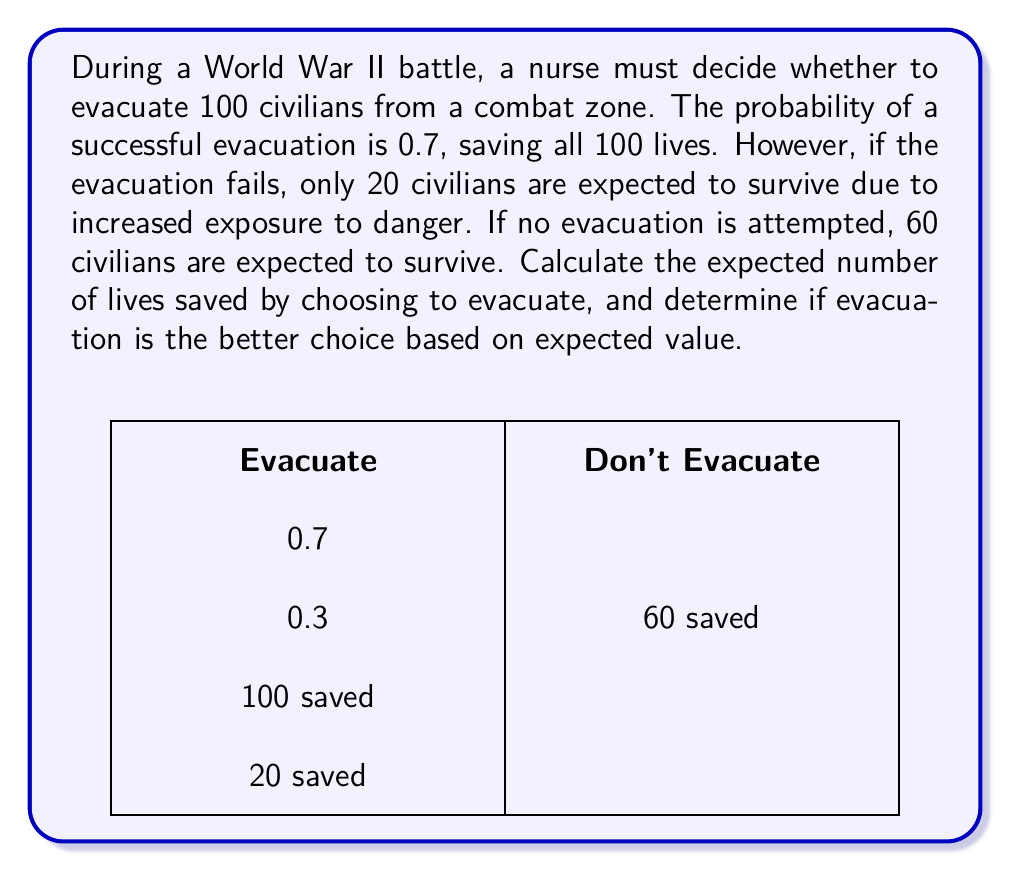Solve this math problem. Let's approach this step-by-step using decision theory and expected value calculations:

1) First, let's define our options and their outcomes:
   Option A: Evacuate
   - Success (probability 0.7): 100 lives saved
   - Failure (probability 0.3): 20 lives saved
   Option B: Don't Evacuate
   - 60 lives saved with certainty

2) Calculate the expected value of lives saved for Option A (Evacuate):
   $$E(A) = 0.7 \times 100 + 0.3 \times 20$$
   $$E(A) = 70 + 6 = 76$$

3) The expected value of Option B (Don't Evacuate) is simply 60, as it's a certain outcome.

4) Compare the expected values:
   Option A (Evacuate): 76 lives saved
   Option B (Don't Evacuate): 60 lives saved

5) Calculate the difference in expected lives saved:
   $$\text{Difference} = E(A) - E(B) = 76 - 60 = 16$$

Therefore, choosing to evacuate is expected to save 16 more lives on average compared to not evacuating. Based on expected value, evacuation is the better choice.
Answer: 76 lives; Yes, evacuate 